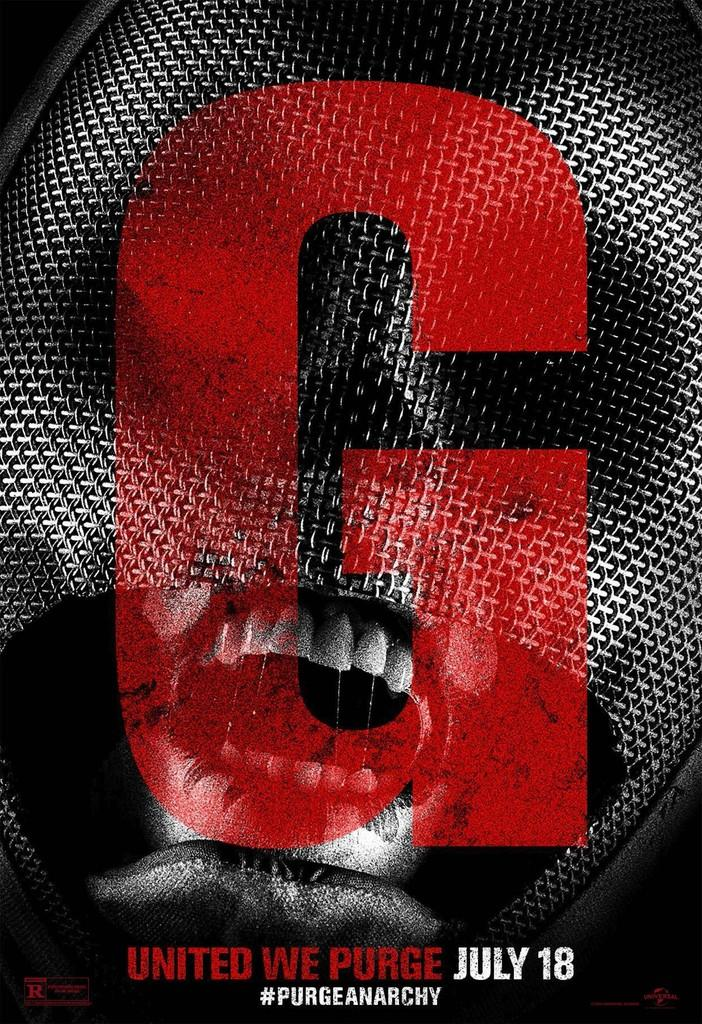<image>
Summarize the visual content of the image. an ad for G United WE Purge on July 18 